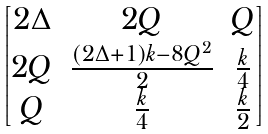<formula> <loc_0><loc_0><loc_500><loc_500>\begin{bmatrix} 2 \Delta & 2 Q & Q \\ 2 Q & \frac { ( 2 \Delta + 1 ) k - 8 Q ^ { 2 } } { 2 } & \frac { k } { 4 } \\ Q & \frac { k } { 4 } & \frac { k } { 2 } \end{bmatrix}</formula> 